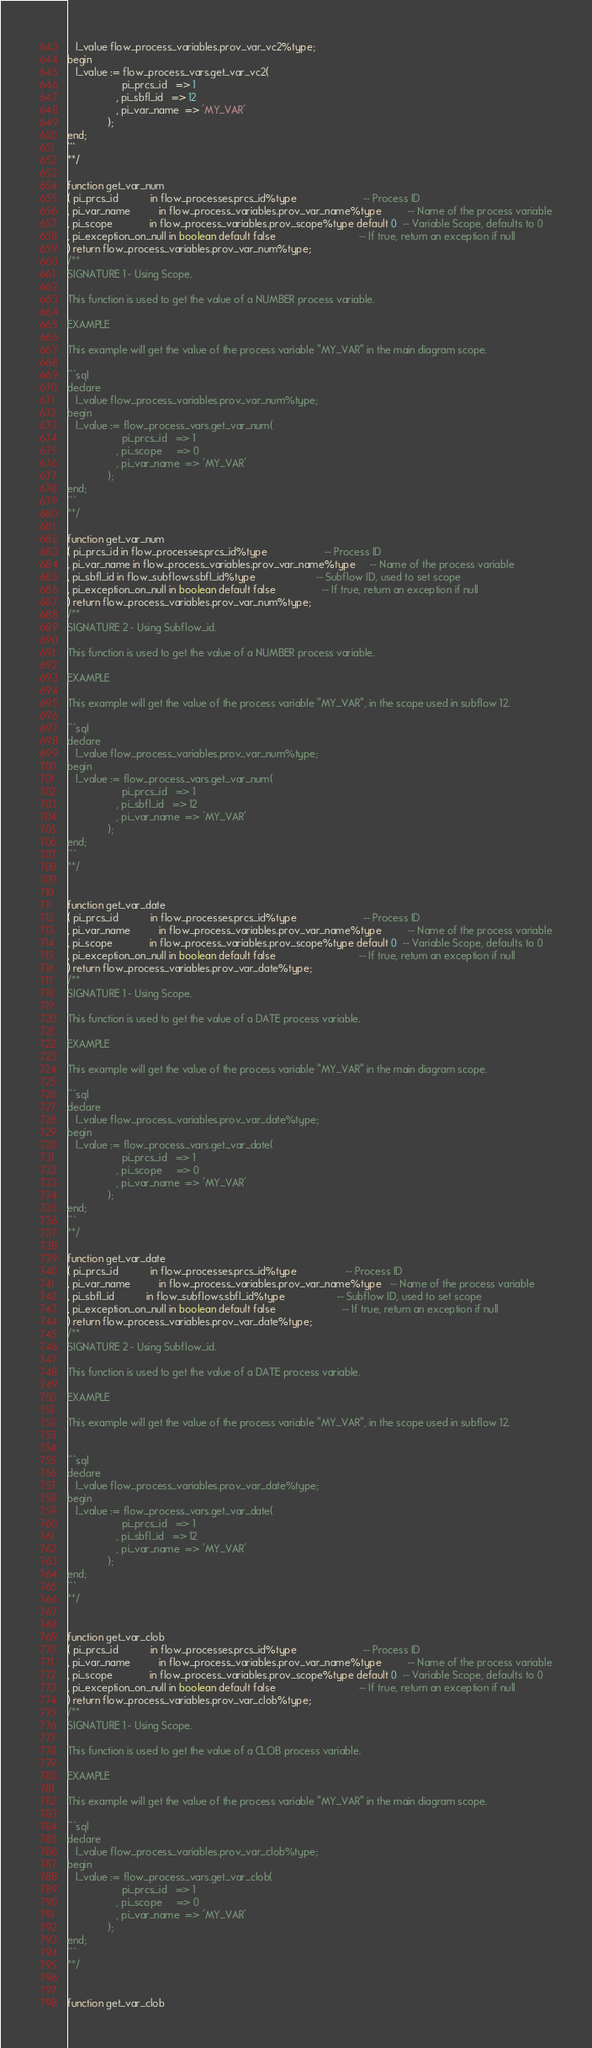Convert code to text. <code><loc_0><loc_0><loc_500><loc_500><_SQL_>   l_value flow_process_variables.prov_var_vc2%type;
begin
   l_value := flow_process_vars.get_var_vc2(
                   pi_prcs_id   => 1
                 , pi_sbfl_id   => 12
                 , pi_var_name  => 'MY_VAR'
              );
end;
```
**/

function get_var_num
( pi_prcs_id           in flow_processes.prcs_id%type                       -- Process ID
, pi_var_name          in flow_process_variables.prov_var_name%type         -- Name of the process variable
, pi_scope             in flow_process_variables.prov_scope%type default 0  -- Variable Scope, defaults to 0
, pi_exception_on_null in boolean default false                             -- If true, return an exception if null
) return flow_process_variables.prov_var_num%type;
/**
SIGNATURE 1 - Using Scope.

This function is used to get the value of a NUMBER process variable.

EXAMPLE

This example will get the value of the process variable "MY_VAR" in the main diagram scope.

```sql
declare
   l_value flow_process_variables.prov_var_num%type;
begin
   l_value := flow_process_vars.get_var_num(
                   pi_prcs_id   => 1
                 , pi_scope     => 0
                 , pi_var_name  => 'MY_VAR'
              );
end;
```
**/

function get_var_num
( pi_prcs_id in flow_processes.prcs_id%type                    -- Process ID
, pi_var_name in flow_process_variables.prov_var_name%type     -- Name of the process variable
, pi_sbfl_id in flow_subflows.sbfl_id%type                     -- Subflow ID, used to set scope
, pi_exception_on_null in boolean default false                -- If true, return an exception if null
) return flow_process_variables.prov_var_num%type;
/**
SIGNATURE 2 - Using Subflow_id.

This function is used to get the value of a NUMBER process variable.

EXAMPLE

This example will get the value of the process variable "MY_VAR", in the scope used in subflow 12.

```sql
declare
   l_value flow_process_variables.prov_var_num%type;
begin
   l_value := flow_process_vars.get_var_num(
                   pi_prcs_id   => 1
                 , pi_sbfl_id   => 12
                 , pi_var_name  => 'MY_VAR'
              );
end;
```
**/


function get_var_date
( pi_prcs_id           in flow_processes.prcs_id%type                       -- Process ID
, pi_var_name          in flow_process_variables.prov_var_name%type         -- Name of the process variable
, pi_scope             in flow_process_variables.prov_scope%type default 0  -- Variable Scope, defaults to 0
, pi_exception_on_null in boolean default false                             -- If true, return an exception if null
) return flow_process_variables.prov_var_date%type;
/**
SIGNATURE 1 - Using Scope.

This function is used to get the value of a DATE process variable.

EXAMPLE

This example will get the value of the process variable "MY_VAR" in the main diagram scope.

```sql
declare
   l_value flow_process_variables.prov_var_date%type;
begin
   l_value := flow_process_vars.get_var_date(
                   pi_prcs_id   => 1
                 , pi_scope     => 0
                 , pi_var_name  => 'MY_VAR'
              );
end;
```
**/

function get_var_date
( pi_prcs_id           in flow_processes.prcs_id%type                 -- Process ID
, pi_var_name          in flow_process_variables.prov_var_name%type   -- Name of the process variable
, pi_sbfl_id           in flow_subflows.sbfl_id%type                  -- Subflow ID, used to set scope
, pi_exception_on_null in boolean default false                       -- If true, return an exception if null
) return flow_process_variables.prov_var_date%type;
/**
SIGNATURE 2 - Using Subflow_id.

This function is used to get the value of a DATE process variable.

EXAMPLE

This example will get the value of the process variable "MY_VAR", in the scope used in subflow 12.


```sql
declare
   l_value flow_process_variables.prov_var_date%type;
begin
   l_value := flow_process_vars.get_var_date(
                   pi_prcs_id   => 1
                 , pi_sbfl_id   => 12
                 , pi_var_name  => 'MY_VAR'
              );
end;
```
**/


function get_var_clob
( pi_prcs_id           in flow_processes.prcs_id%type                       -- Process ID
, pi_var_name          in flow_process_variables.prov_var_name%type         -- Name of the process variable
, pi_scope             in flow_process_variables.prov_scope%type default 0  -- Variable Scope, defaults to 0
, pi_exception_on_null in boolean default false                             -- If true, return an exception if null
) return flow_process_variables.prov_var_clob%type;
/**
SIGNATURE 1 - Using Scope.

This function is used to get the value of a CLOB process variable.

EXAMPLE

This example will get the value of the process variable "MY_VAR" in the main diagram scope.

```sql
declare
   l_value flow_process_variables.prov_var_clob%type;
begin
   l_value := flow_process_vars.get_var_clob(
                   pi_prcs_id   => 1
                 , pi_scope     => 0
                 , pi_var_name  => 'MY_VAR'
              );
end;
```
**/


function get_var_clob</code> 